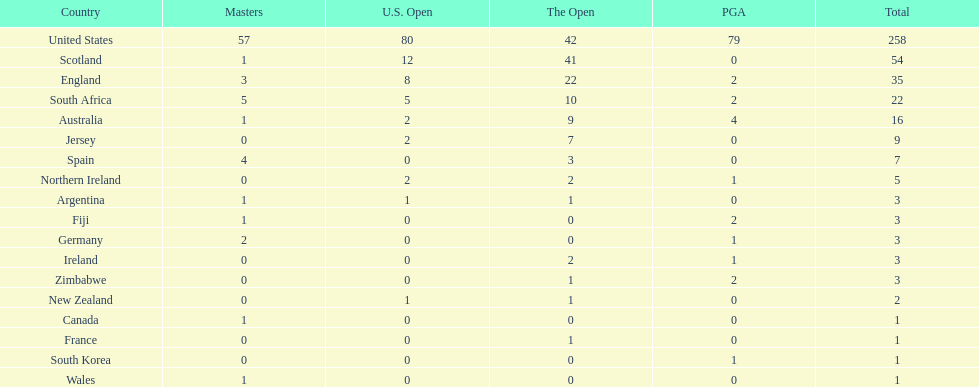Which country has the most pga championships. United States. 